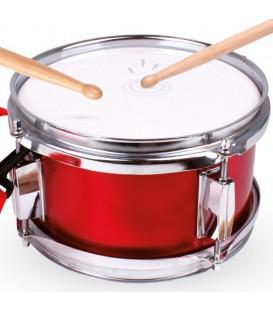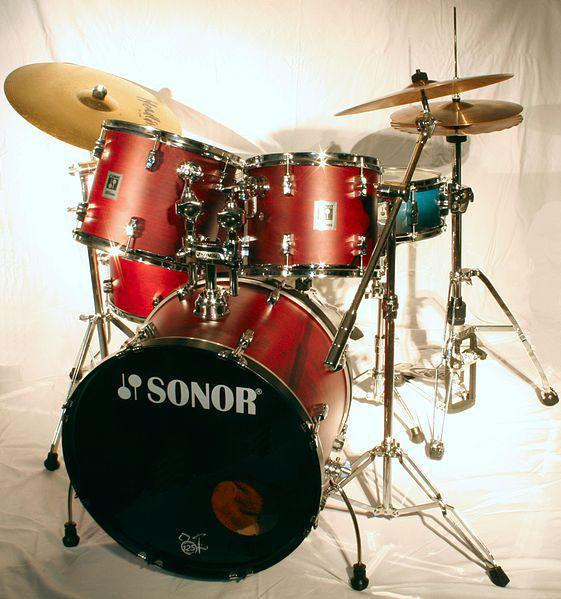The first image is the image on the left, the second image is the image on the right. Examine the images to the left and right. Is the description "The left image shows three pedestal-shaped drums with wood-grain exteriors, and the right image shows at least three white drums with black rims." accurate? Answer yes or no. No. The first image is the image on the left, the second image is the image on the right. Evaluate the accuracy of this statement regarding the images: "There are three bongo drums.". Is it true? Answer yes or no. No. 